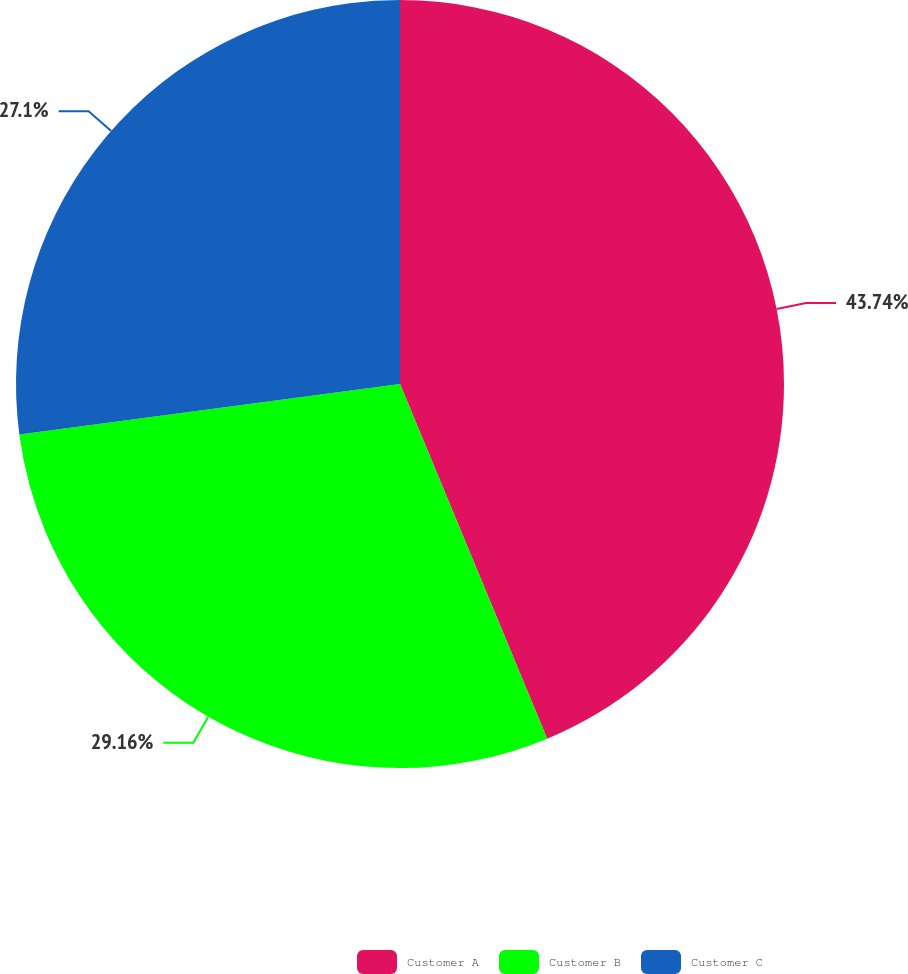<chart> <loc_0><loc_0><loc_500><loc_500><pie_chart><fcel>Customer A<fcel>Customer B<fcel>Customer C<nl><fcel>43.74%<fcel>29.16%<fcel>27.1%<nl></chart> 